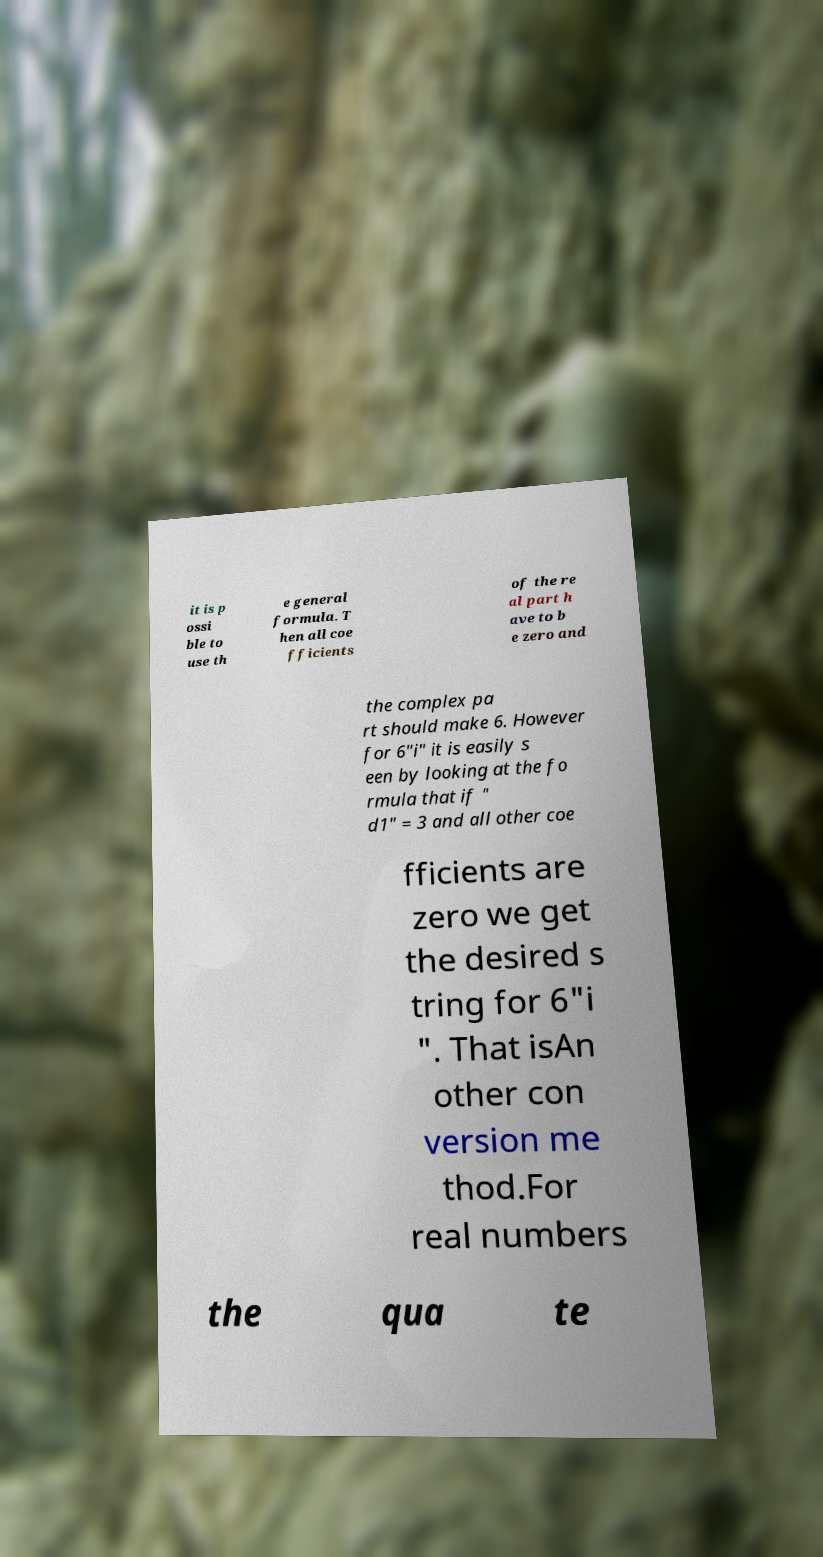For documentation purposes, I need the text within this image transcribed. Could you provide that? it is p ossi ble to use th e general formula. T hen all coe fficients of the re al part h ave to b e zero and the complex pa rt should make 6. However for 6"i" it is easily s een by looking at the fo rmula that if " d1" = 3 and all other coe fficients are zero we get the desired s tring for 6"i ". That isAn other con version me thod.For real numbers the qua te 